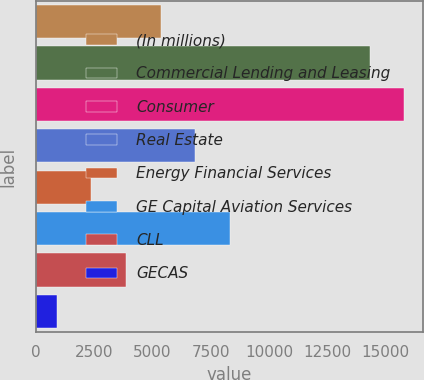<chart> <loc_0><loc_0><loc_500><loc_500><bar_chart><fcel>(In millions)<fcel>Commercial Lending and Leasing<fcel>Consumer<fcel>Real Estate<fcel>Energy Financial Services<fcel>GE Capital Aviation Services<fcel>CLL<fcel>GECAS<nl><fcel>5349.5<fcel>14316<fcel>15800.5<fcel>6834<fcel>2380.5<fcel>8318.5<fcel>3865<fcel>896<nl></chart> 